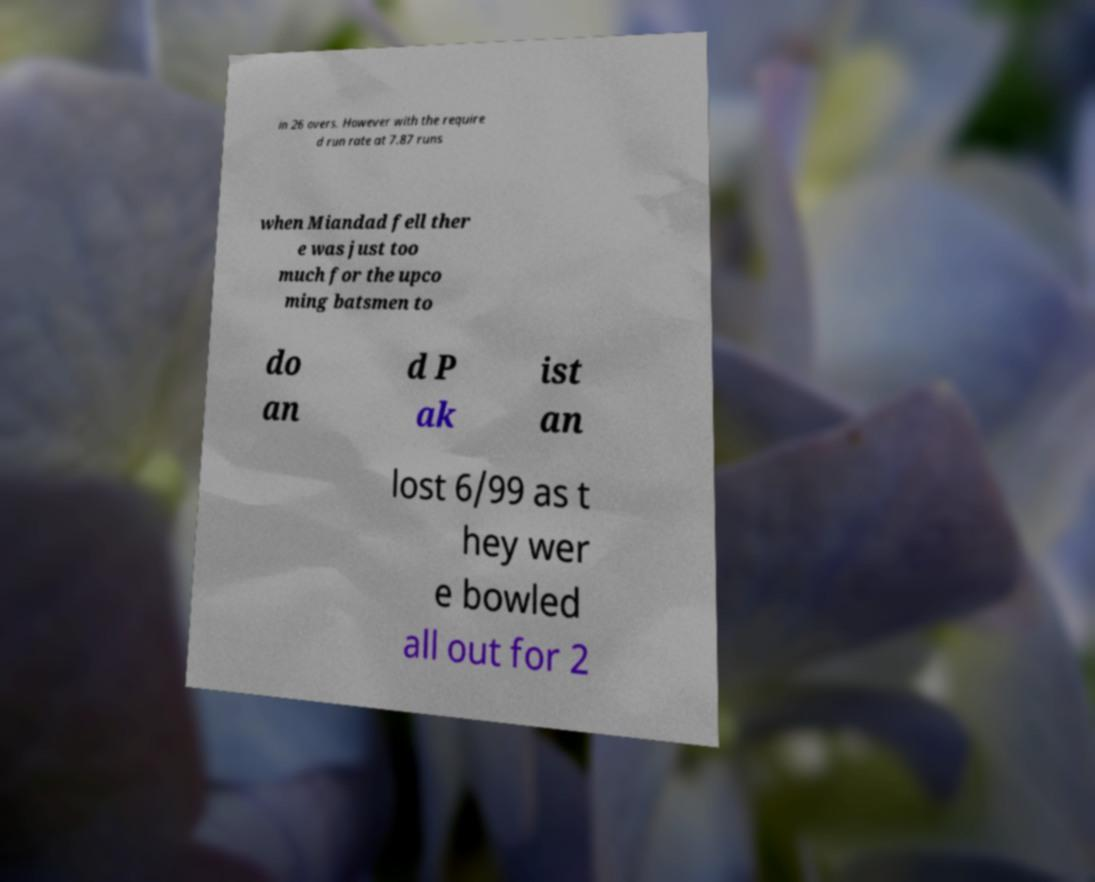Please identify and transcribe the text found in this image. in 26 overs. However with the require d run rate at 7.87 runs when Miandad fell ther e was just too much for the upco ming batsmen to do an d P ak ist an lost 6/99 as t hey wer e bowled all out for 2 